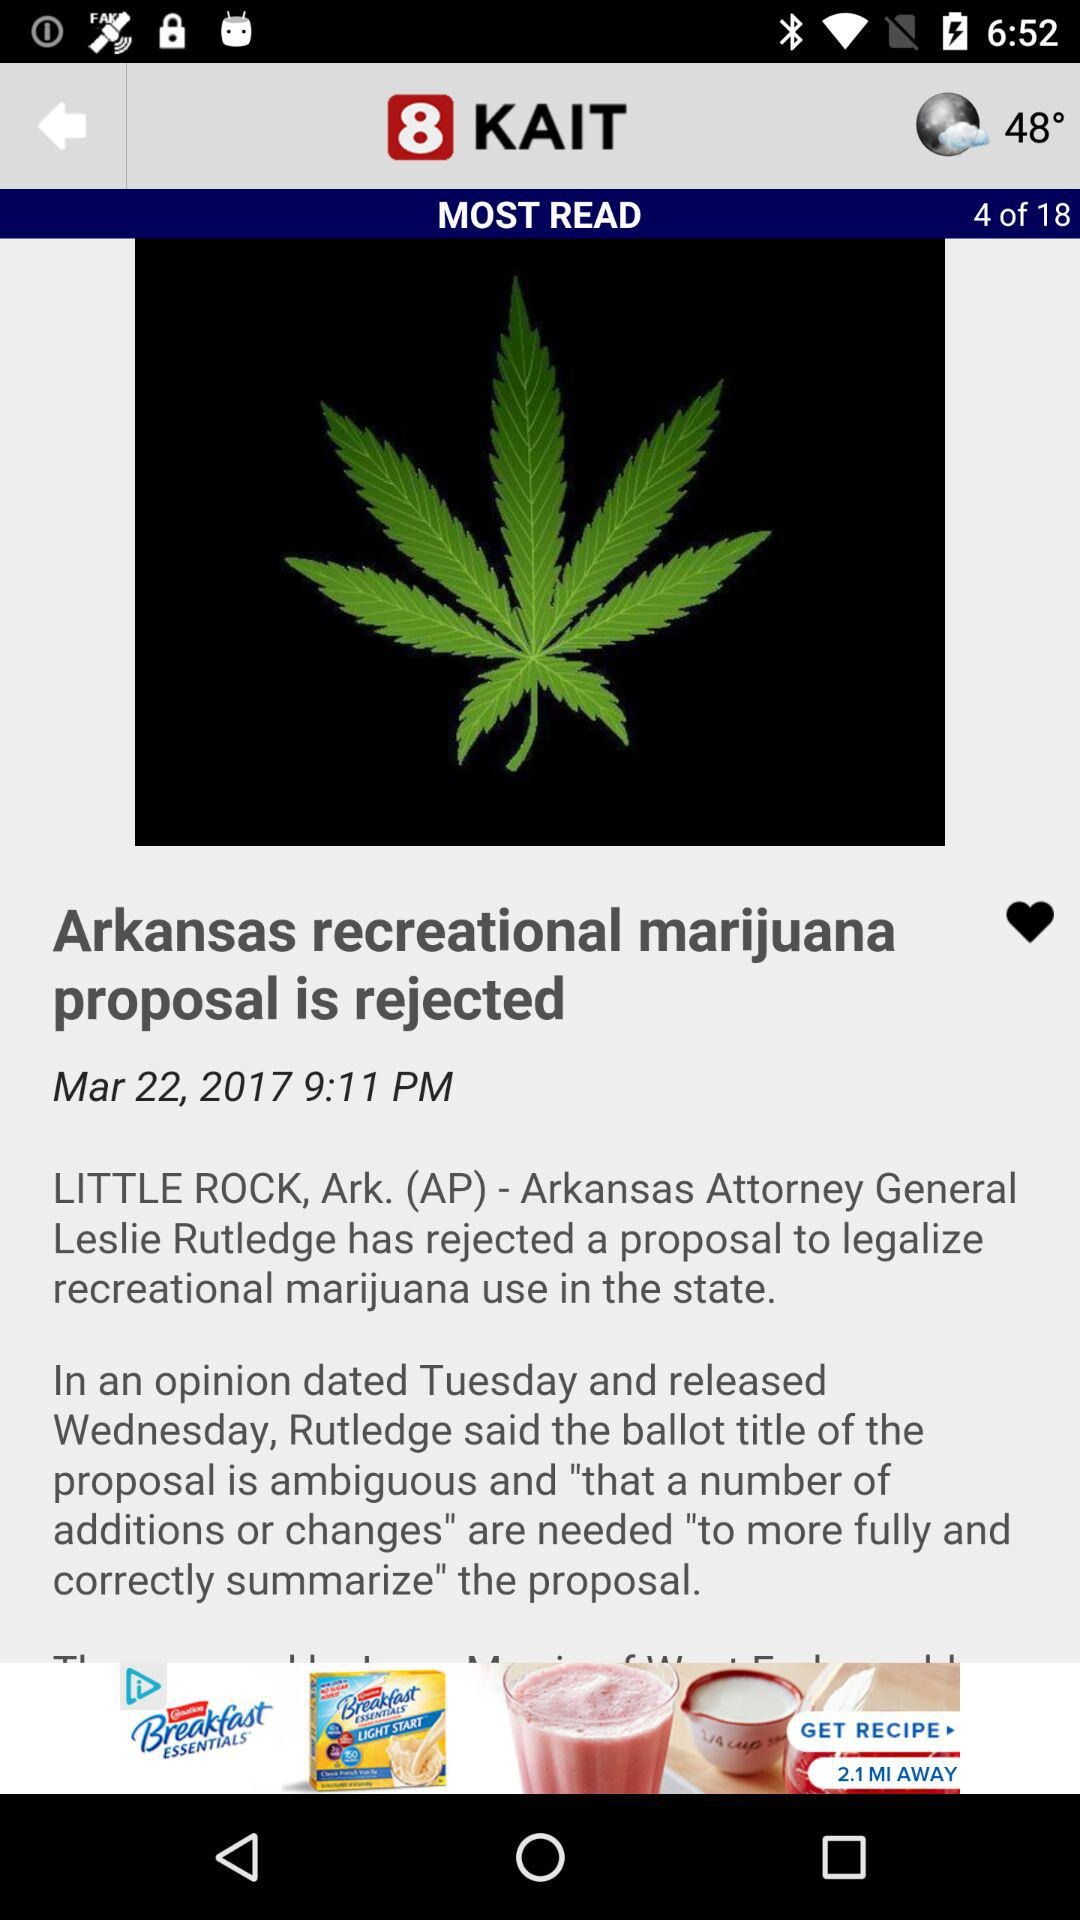What is the publication date of this article? The publication date is March 22, 2017. 